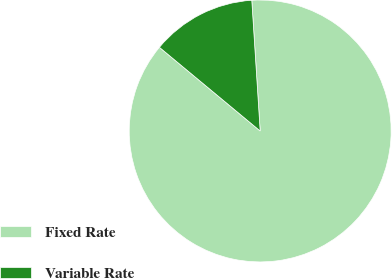Convert chart to OTSL. <chart><loc_0><loc_0><loc_500><loc_500><pie_chart><fcel>Fixed Rate<fcel>Variable Rate<nl><fcel>87.05%<fcel>12.95%<nl></chart> 